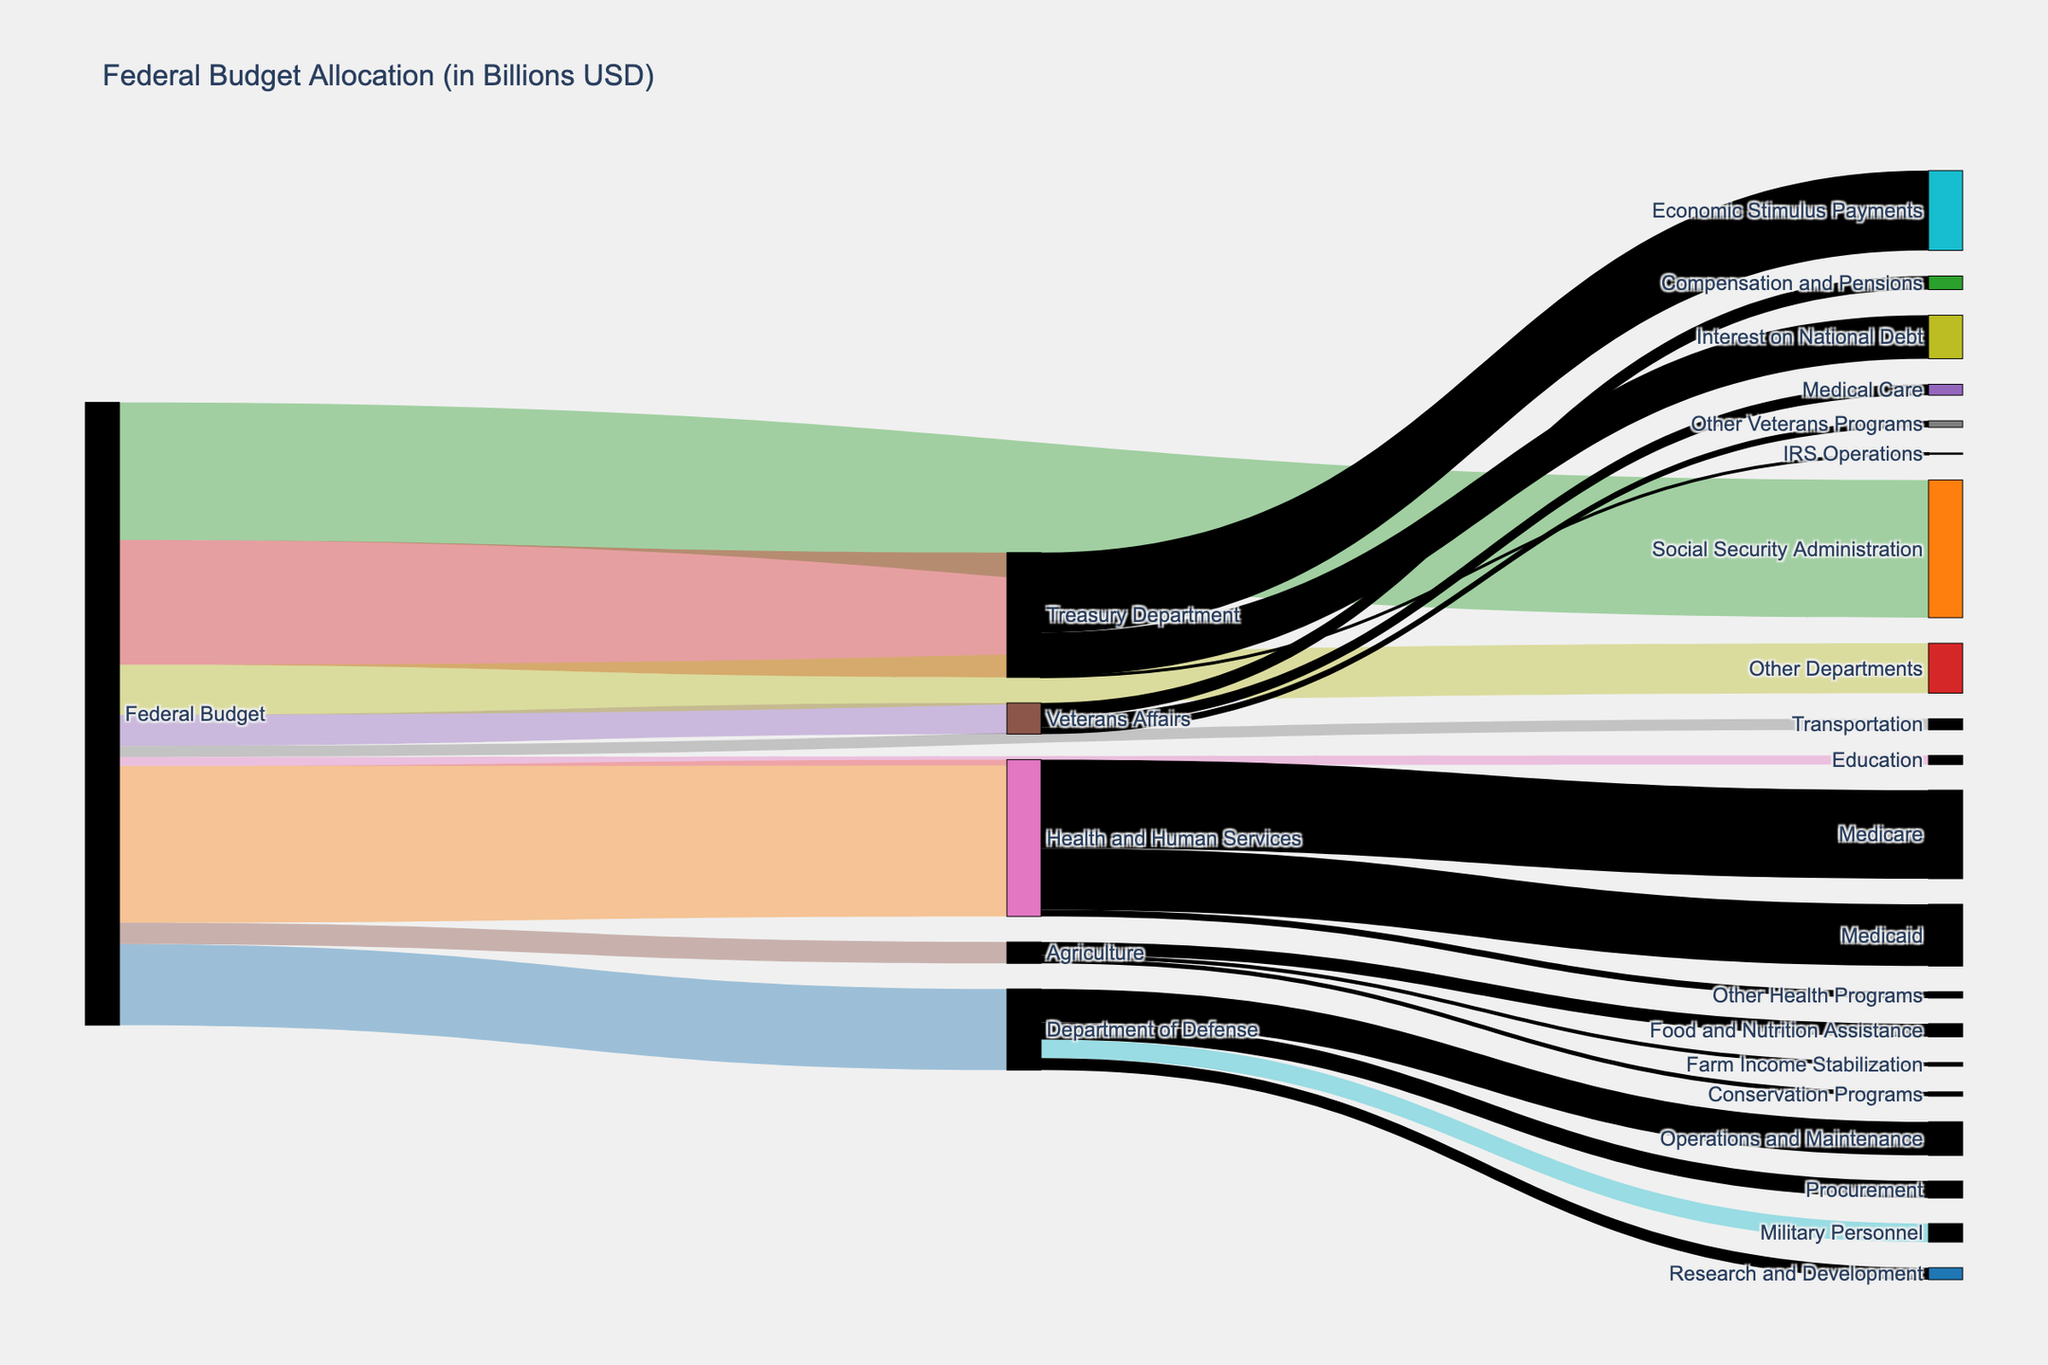What is the largest department allocation from the Federal Budget? The largest allocation from the Federal Budget can be identified by the width of the flow connecting the Federal Budget to the departments. The widest flow goes to Health and Human Services.
Answer: Health and Human Services How much is allocated to the Department of Defense compared to the Treasury Department? The amount allocated to the Department of Defense is 704.6 billion USD, while the Treasury Department receives 1083.9 billion USD. Comparing these values, the Treasury Department gets more funding.
Answer: Treasury Department gets more funding What are the three largest allocations within Health and Human Services? The flow within Health and Human Services branches into three allocations: Medicare, Medicaid, and Other Health Programs. By comparing the widths, Medicare (769.5 billion USD) and Medicaid (536.7 billion USD) are significantly larger than Other Health Programs (56.0 billion USD).
Answer: Medicare, Medicaid, Other Health Programs What is the total amount allocated to Military Personnel and Operations and Maintenance within the Department of Defense? To find the total, sum the allocations to Military Personnel and Operations and Maintenance within the Department of Defense: 161.3 billion USD + 291.9 billion USD = 453.2 billion USD.
Answer: 453.2 billion USD Which specific program within the Treasury Department receives the most funding? Within the Treasury Department, the largest allocation can be seen as the widest flow, which goes to Economic Stimulus Payments at 693.1 billion USD.
Answer: Economic Stimulus Payments How much more funding does the Social Security Administration receive compared to the Veterans Affairs? The Social Security Administration receives 1196.3 billion USD, and Veterans Affairs receives 269.9 billion USD. Subtracting these gives 1196.3 - 269.9 = 926.4 billion USD.
Answer: 926.4 billion USD What are the total funds allocated to social support programs (Health and Human Services and Social Security Administration)? Adding the funds allocated to Health and Human Services (1362.2 billion USD) and the Social Security Administration (1196.3 billion USD), we get a total of 1362.2 + 1196.3 = 2558.5 billion USD.
Answer: 2558.5 billion USD Which program within the Agriculture Department receives the least funding? Examining the flows within the Agriculture Department, Conservation Programs receive the least at 37.8 billion USD.
Answer: Conservation Programs By how much does the funding for Medicare exceed that for Medicaid within Health and Human Services? Medicare receives 769.5 billion USD, while Medicaid receives 536.7 billion USD. The difference is 769.5 - 536.7 = 232.8 billion USD.
Answer: 232.8 billion USD 